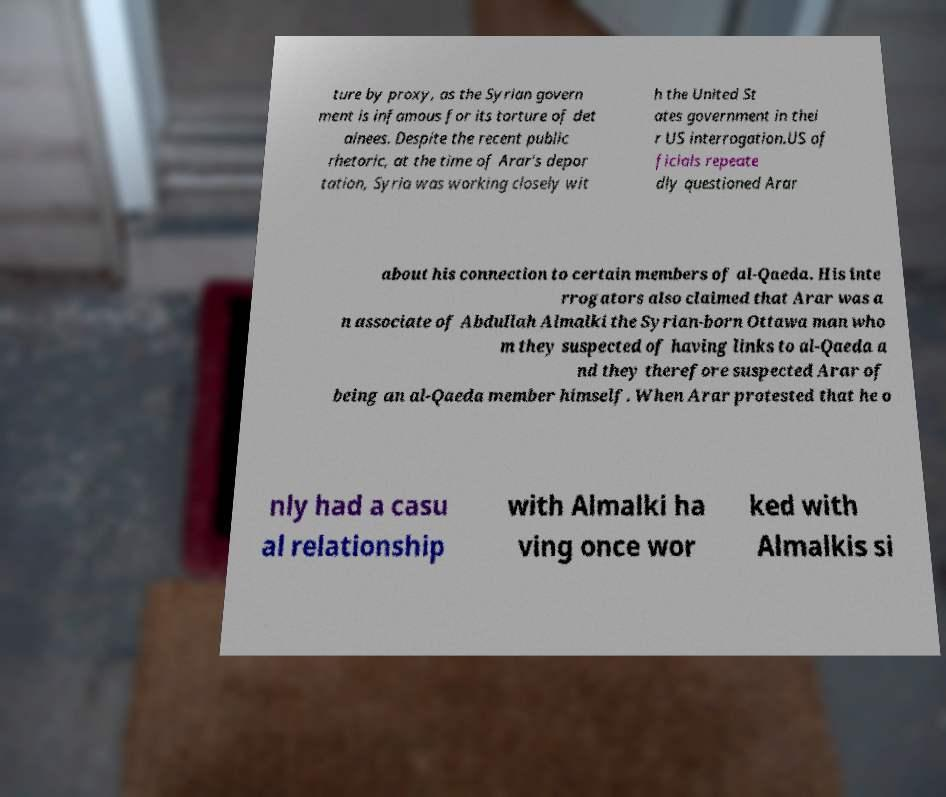For documentation purposes, I need the text within this image transcribed. Could you provide that? ture by proxy, as the Syrian govern ment is infamous for its torture of det ainees. Despite the recent public rhetoric, at the time of Arar's depor tation, Syria was working closely wit h the United St ates government in thei r US interrogation.US of ficials repeate dly questioned Arar about his connection to certain members of al-Qaeda. His inte rrogators also claimed that Arar was a n associate of Abdullah Almalki the Syrian-born Ottawa man who m they suspected of having links to al-Qaeda a nd they therefore suspected Arar of being an al-Qaeda member himself. When Arar protested that he o nly had a casu al relationship with Almalki ha ving once wor ked with Almalkis si 